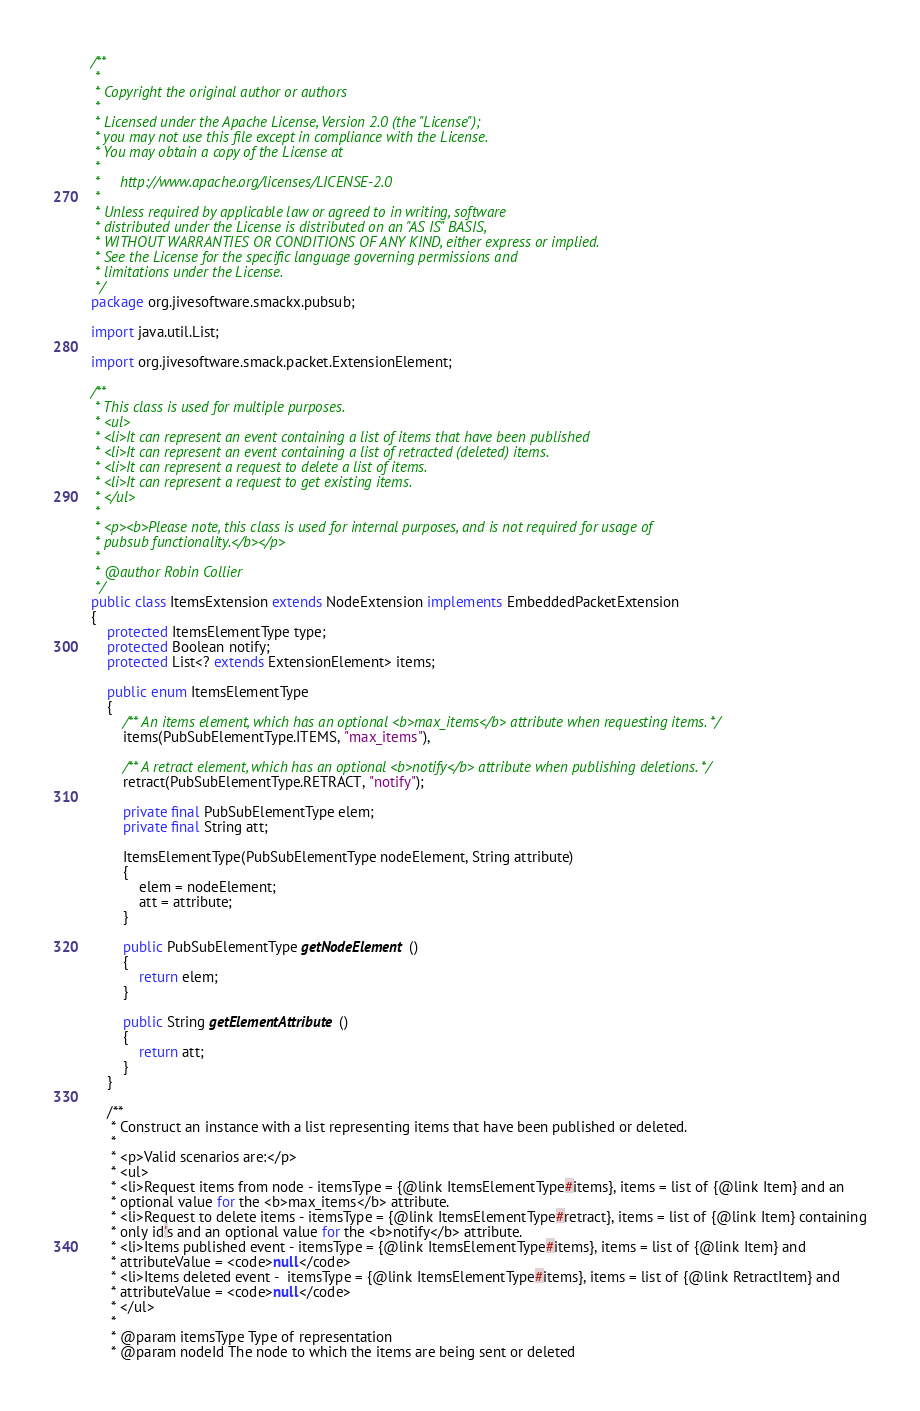<code> <loc_0><loc_0><loc_500><loc_500><_Java_>/**
 *
 * Copyright the original author or authors
 *
 * Licensed under the Apache License, Version 2.0 (the "License");
 * you may not use this file except in compliance with the License.
 * You may obtain a copy of the License at
 *
 *     http://www.apache.org/licenses/LICENSE-2.0
 *
 * Unless required by applicable law or agreed to in writing, software
 * distributed under the License is distributed on an "AS IS" BASIS,
 * WITHOUT WARRANTIES OR CONDITIONS OF ANY KIND, either express or implied.
 * See the License for the specific language governing permissions and
 * limitations under the License.
 */
package org.jivesoftware.smackx.pubsub;

import java.util.List;

import org.jivesoftware.smack.packet.ExtensionElement;

/**
 * This class is used for multiple purposes.
 * <ul>
 * <li>It can represent an event containing a list of items that have been published
 * <li>It can represent an event containing a list of retracted (deleted) items.
 * <li>It can represent a request to delete a list of items.
 * <li>It can represent a request to get existing items.
 * </ul>
 * 
 * <p><b>Please note, this class is used for internal purposes, and is not required for usage of 
 * pubsub functionality.</b></p>
 * 
 * @author Robin Collier
 */
public class ItemsExtension extends NodeExtension implements EmbeddedPacketExtension
{
    protected ItemsElementType type;
    protected Boolean notify;
    protected List<? extends ExtensionElement> items;

    public enum ItemsElementType
    {
        /** An items element, which has an optional <b>max_items</b> attribute when requesting items. */
        items(PubSubElementType.ITEMS, "max_items"),

        /** A retract element, which has an optional <b>notify</b> attribute when publishing deletions. */
        retract(PubSubElementType.RETRACT, "notify");

        private final PubSubElementType elem;
        private final String att;

        ItemsElementType(PubSubElementType nodeElement, String attribute)
        {
            elem = nodeElement;
            att = attribute;
        }

        public PubSubElementType getNodeElement()
        {
            return elem;
        }

        public String getElementAttribute()
        {
            return att;
        }
    }

    /**
     * Construct an instance with a list representing items that have been published or deleted.
     * 
     * <p>Valid scenarios are:</p>
     * <ul>
     * <li>Request items from node - itemsType = {@link ItemsElementType#items}, items = list of {@link Item} and an
     * optional value for the <b>max_items</b> attribute.
     * <li>Request to delete items - itemsType = {@link ItemsElementType#retract}, items = list of {@link Item} containing
     * only id's and an optional value for the <b>notify</b> attribute.
     * <li>Items published event - itemsType = {@link ItemsElementType#items}, items = list of {@link Item} and 
     * attributeValue = <code>null</code>
     * <li>Items deleted event -  itemsType = {@link ItemsElementType#items}, items = list of {@link RetractItem} and 
     * attributeValue = <code>null</code> 
     * </ul>
     * 
     * @param itemsType Type of representation
     * @param nodeId The node to which the items are being sent or deleted</code> 